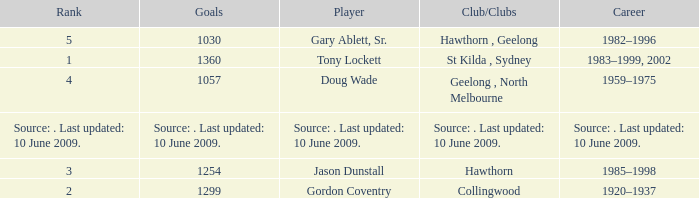What is the rank of player Jason Dunstall? 3.0. Can you give me this table as a dict? {'header': ['Rank', 'Goals', 'Player', 'Club/Clubs', 'Career'], 'rows': [['5', '1030', 'Gary Ablett, Sr.', 'Hawthorn , Geelong', '1982–1996'], ['1', '1360', 'Tony Lockett', 'St Kilda , Sydney', '1983–1999, 2002'], ['4', '1057', 'Doug Wade', 'Geelong , North Melbourne', '1959–1975'], ['Source: . Last updated: 10 June 2009.', 'Source: . Last updated: 10 June 2009.', 'Source: . Last updated: 10 June 2009.', 'Source: . Last updated: 10 June 2009.', 'Source: . Last updated: 10 June 2009.'], ['3', '1254', 'Jason Dunstall', 'Hawthorn', '1985–1998'], ['2', '1299', 'Gordon Coventry', 'Collingwood', '1920–1937']]} 